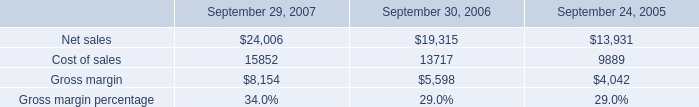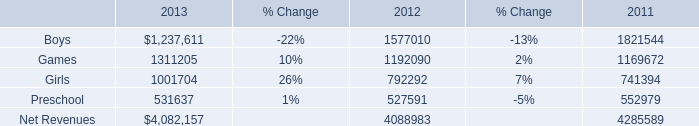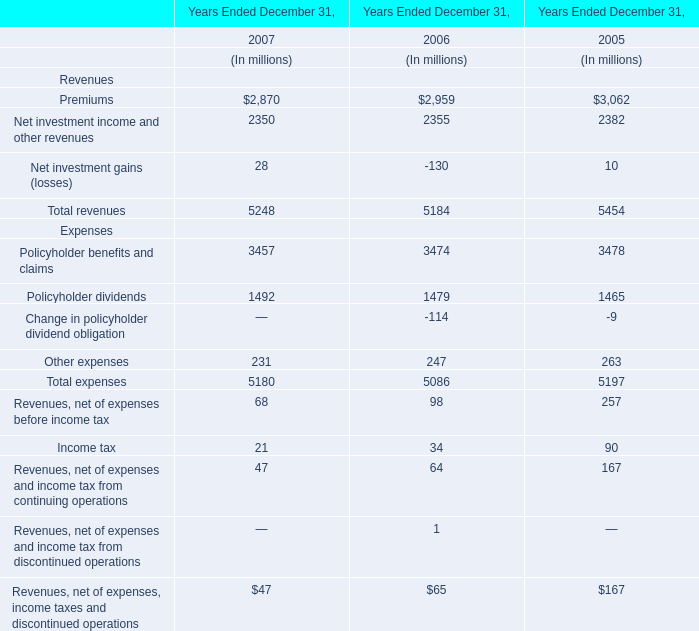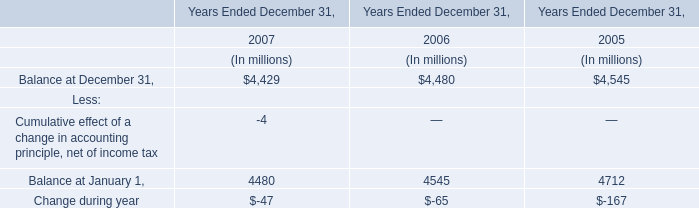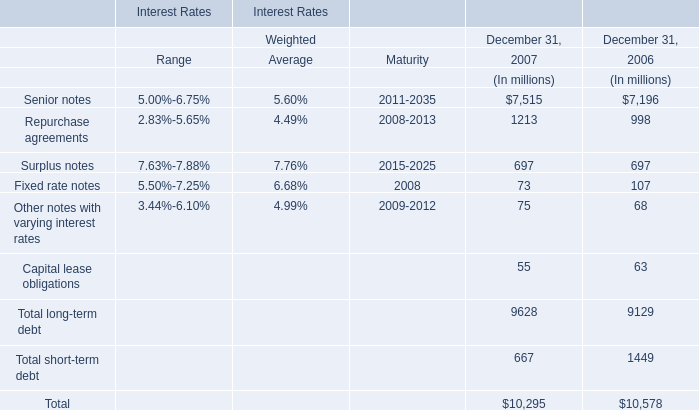What was the total amount of Expenses in the range of 30 and 100 in 2008? (in million) 
Computations: ((64 + 98) + 34)
Answer: 196.0. 